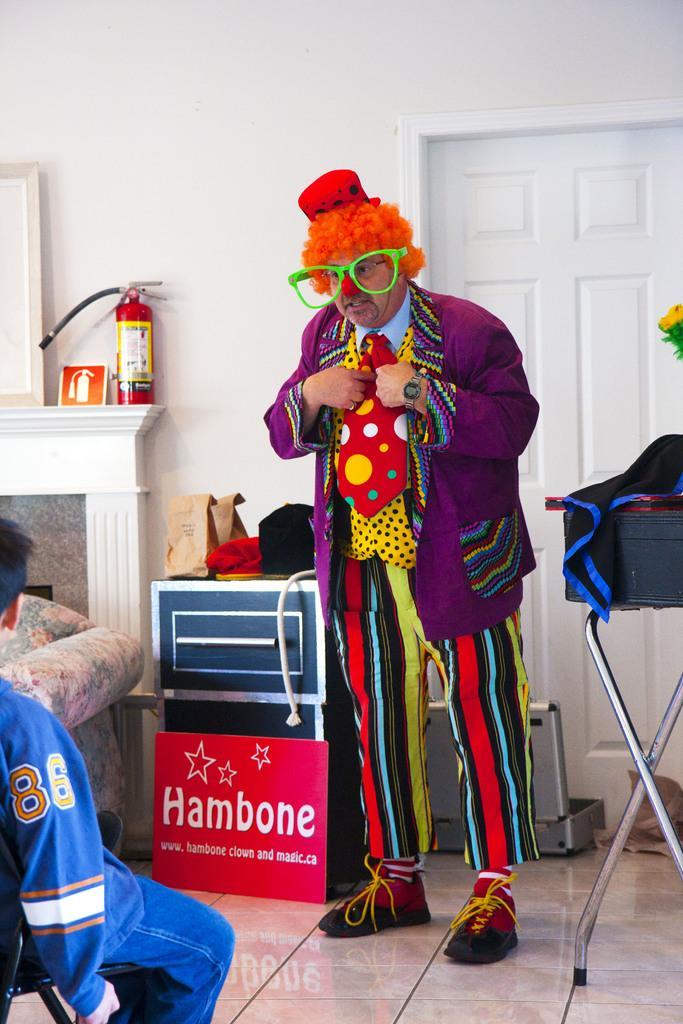How would you summarize this image in a sentence or two? This picture is clicked inside. On the left there is a person sitting on the chair. In the center there is a man standing on the ground and there are some objects placed on the ground. In the background we can see the fire extinguisher, fireplace, wall and a door. 